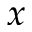Convert formula to latex. <formula><loc_0><loc_0><loc_500><loc_500>x</formula> 